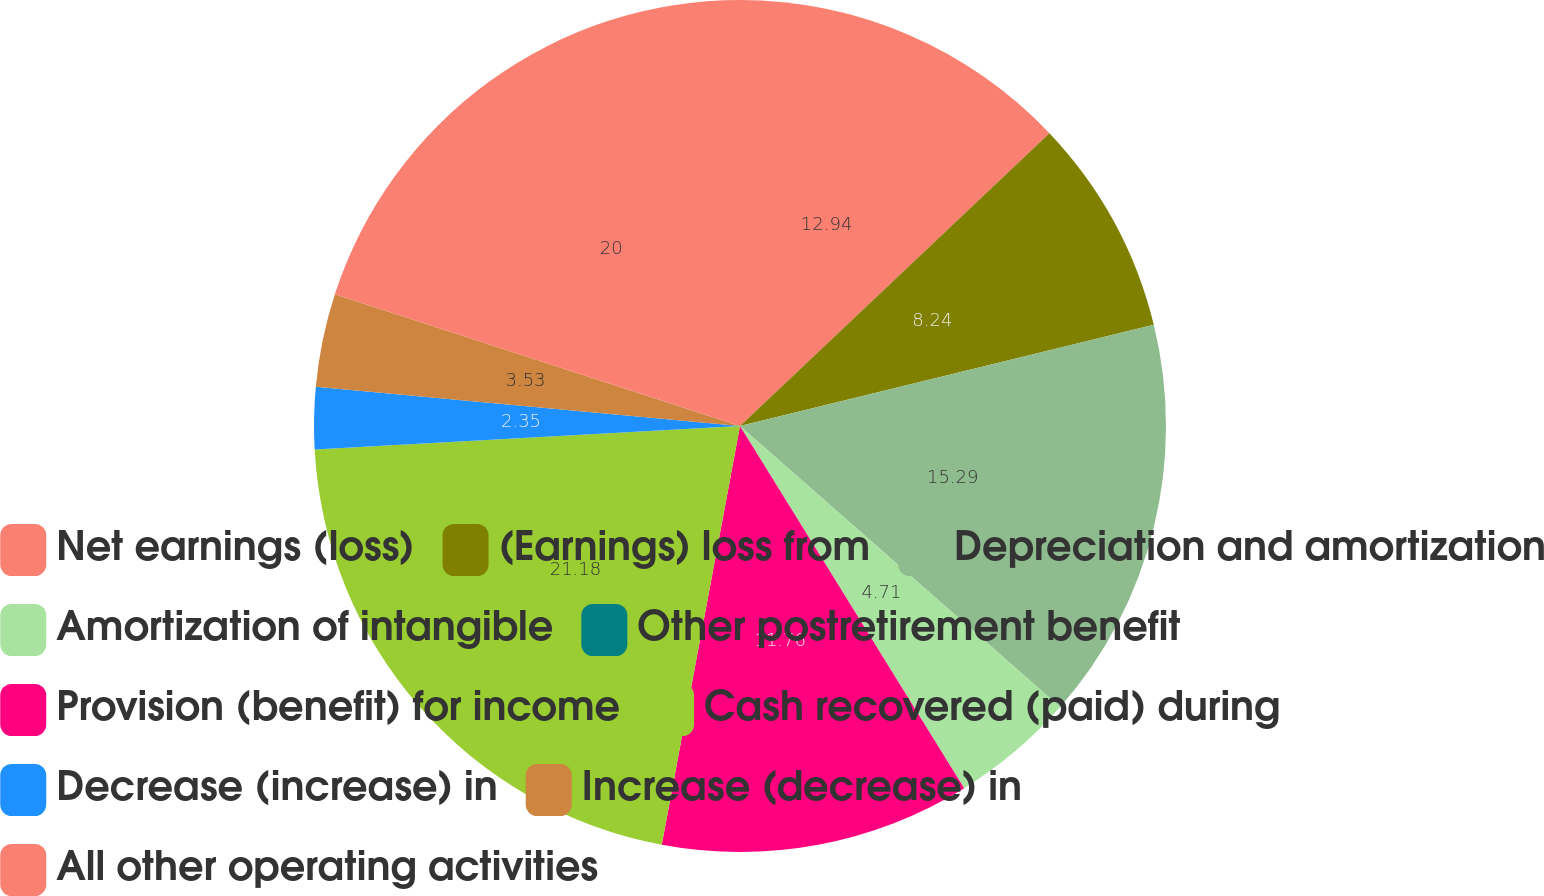Convert chart to OTSL. <chart><loc_0><loc_0><loc_500><loc_500><pie_chart><fcel>Net earnings (loss)<fcel>(Earnings) loss from<fcel>Depreciation and amortization<fcel>Amortization of intangible<fcel>Other postretirement benefit<fcel>Provision (benefit) for income<fcel>Cash recovered (paid) during<fcel>Decrease (increase) in<fcel>Increase (decrease) in<fcel>All other operating activities<nl><fcel>12.94%<fcel>8.24%<fcel>15.29%<fcel>4.71%<fcel>0.0%<fcel>11.76%<fcel>21.18%<fcel>2.35%<fcel>3.53%<fcel>20.0%<nl></chart> 